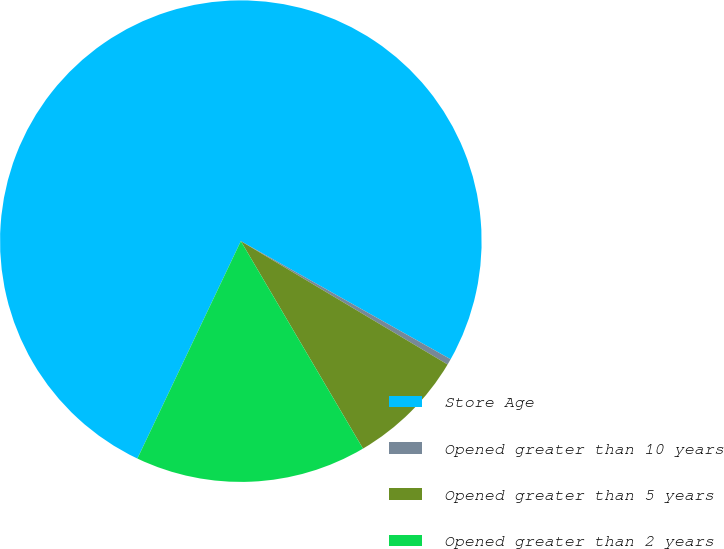Convert chart to OTSL. <chart><loc_0><loc_0><loc_500><loc_500><pie_chart><fcel>Store Age<fcel>Opened greater than 10 years<fcel>Opened greater than 5 years<fcel>Opened greater than 2 years<nl><fcel>76.1%<fcel>0.4%<fcel>7.97%<fcel>15.54%<nl></chart> 